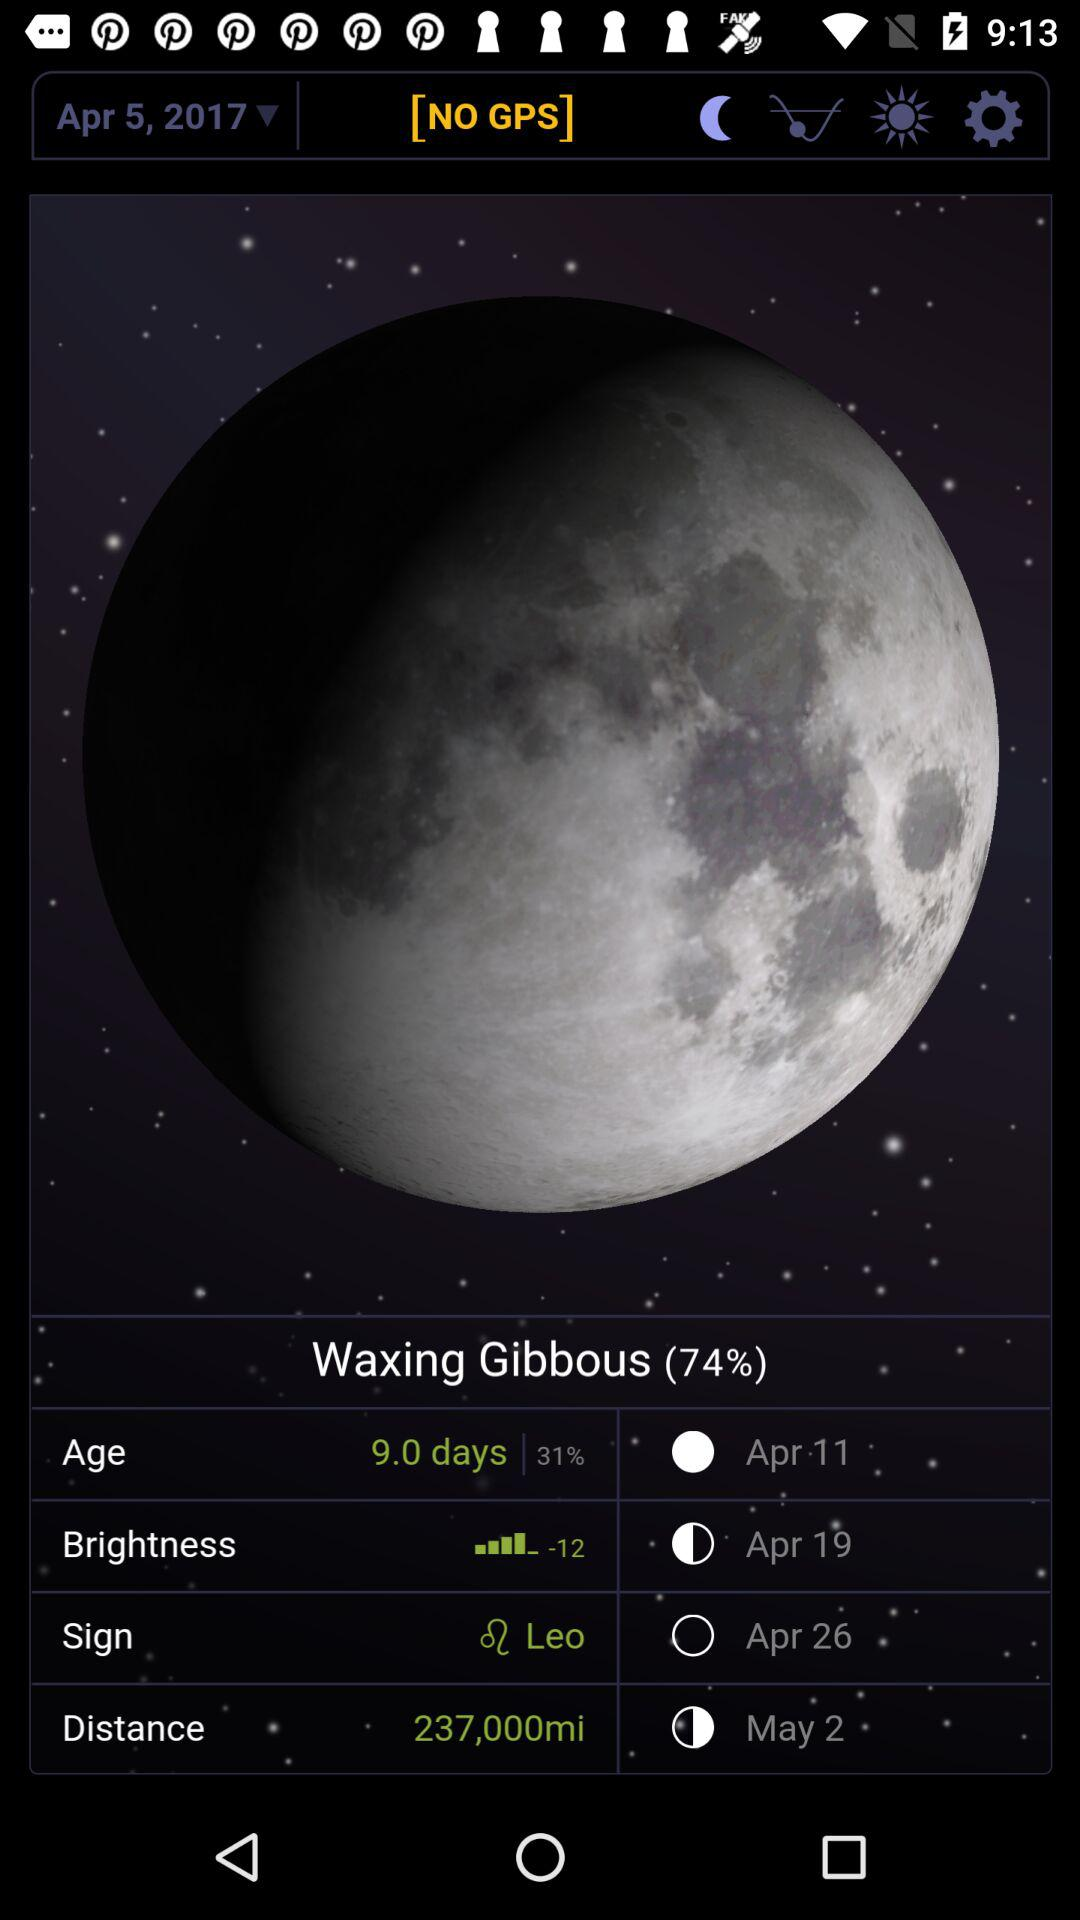What is the distance? The distance is 237,000 miles. 